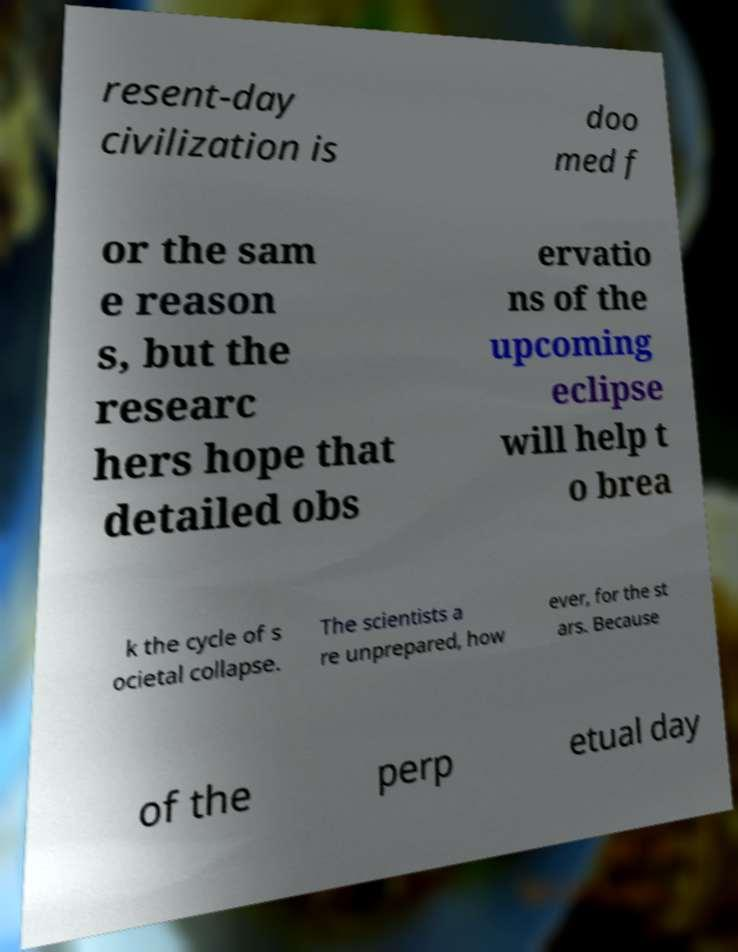Can you accurately transcribe the text from the provided image for me? resent-day civilization is doo med f or the sam e reason s, but the researc hers hope that detailed obs ervatio ns of the upcoming eclipse will help t o brea k the cycle of s ocietal collapse. The scientists a re unprepared, how ever, for the st ars. Because of the perp etual day 